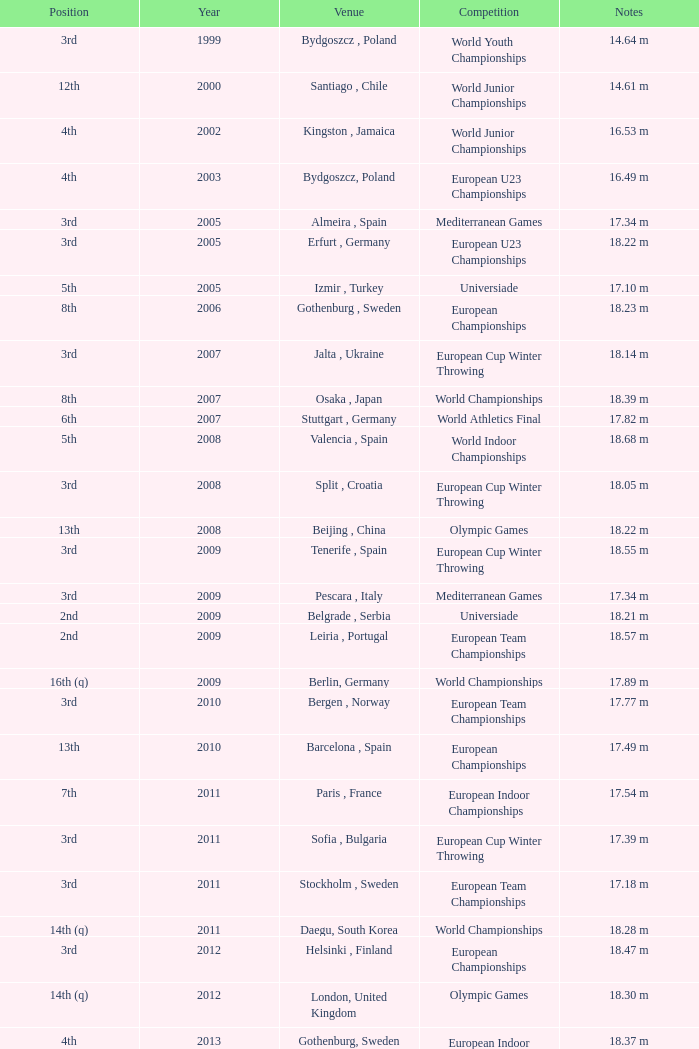What are the notes for bydgoszcz, Poland? 14.64 m, 16.49 m. 